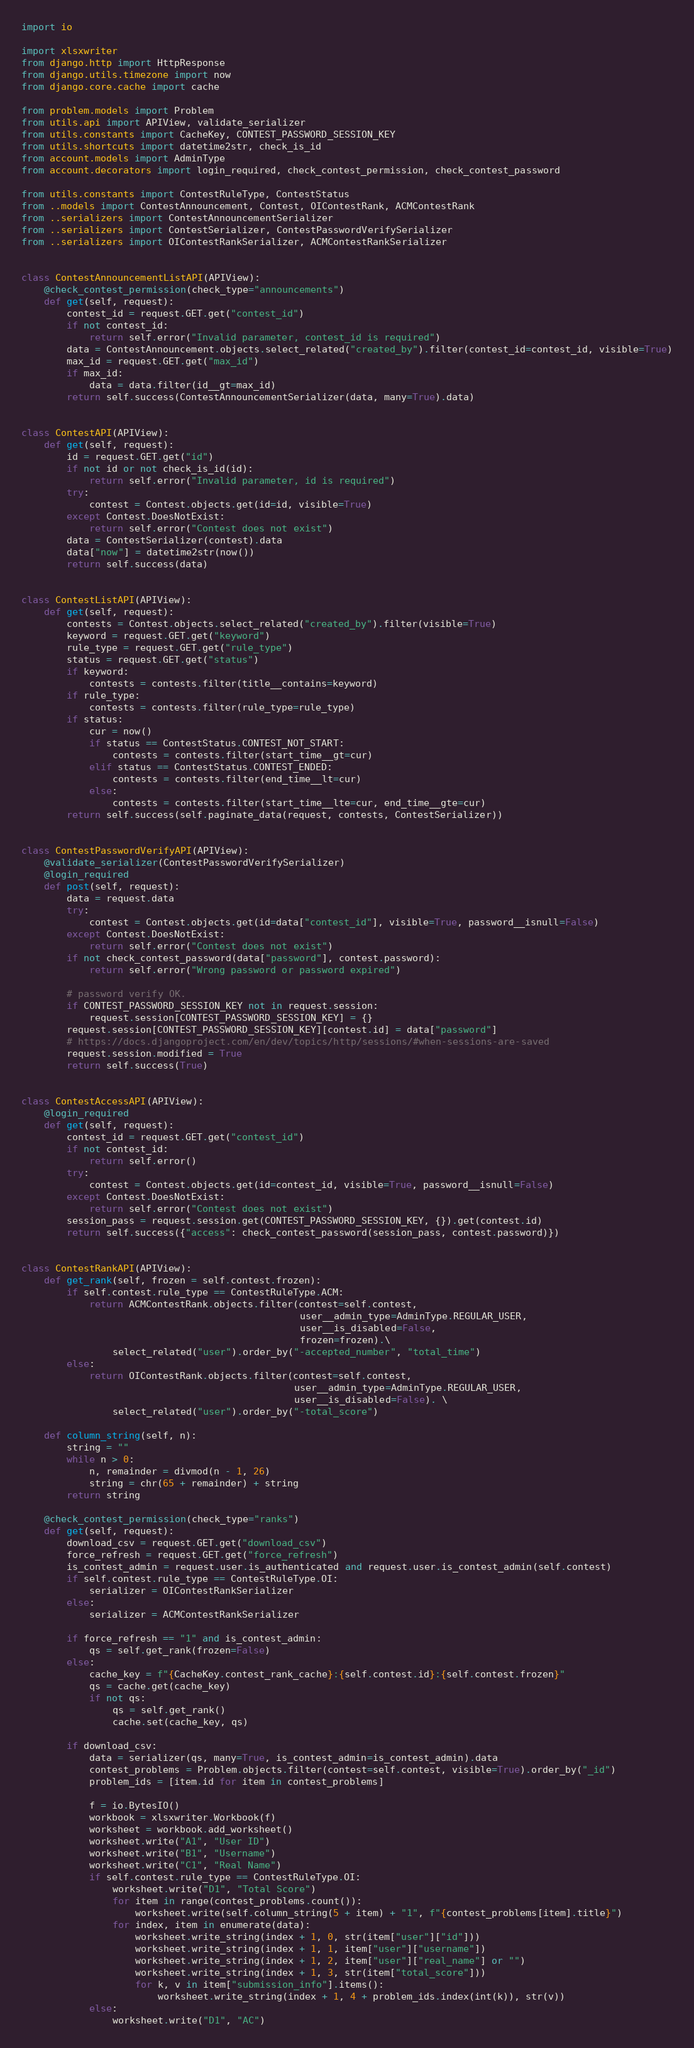<code> <loc_0><loc_0><loc_500><loc_500><_Python_>import io

import xlsxwriter
from django.http import HttpResponse
from django.utils.timezone import now
from django.core.cache import cache

from problem.models import Problem
from utils.api import APIView, validate_serializer
from utils.constants import CacheKey, CONTEST_PASSWORD_SESSION_KEY
from utils.shortcuts import datetime2str, check_is_id
from account.models import AdminType
from account.decorators import login_required, check_contest_permission, check_contest_password

from utils.constants import ContestRuleType, ContestStatus
from ..models import ContestAnnouncement, Contest, OIContestRank, ACMContestRank
from ..serializers import ContestAnnouncementSerializer
from ..serializers import ContestSerializer, ContestPasswordVerifySerializer
from ..serializers import OIContestRankSerializer, ACMContestRankSerializer


class ContestAnnouncementListAPI(APIView):
    @check_contest_permission(check_type="announcements")
    def get(self, request):
        contest_id = request.GET.get("contest_id")
        if not contest_id:
            return self.error("Invalid parameter, contest_id is required")
        data = ContestAnnouncement.objects.select_related("created_by").filter(contest_id=contest_id, visible=True)
        max_id = request.GET.get("max_id")
        if max_id:
            data = data.filter(id__gt=max_id)
        return self.success(ContestAnnouncementSerializer(data, many=True).data)


class ContestAPI(APIView):
    def get(self, request):
        id = request.GET.get("id")
        if not id or not check_is_id(id):
            return self.error("Invalid parameter, id is required")
        try:
            contest = Contest.objects.get(id=id, visible=True)
        except Contest.DoesNotExist:
            return self.error("Contest does not exist")
        data = ContestSerializer(contest).data
        data["now"] = datetime2str(now())
        return self.success(data)


class ContestListAPI(APIView):
    def get(self, request):
        contests = Contest.objects.select_related("created_by").filter(visible=True)
        keyword = request.GET.get("keyword")
        rule_type = request.GET.get("rule_type")
        status = request.GET.get("status")
        if keyword:
            contests = contests.filter(title__contains=keyword)
        if rule_type:
            contests = contests.filter(rule_type=rule_type)
        if status:
            cur = now()
            if status == ContestStatus.CONTEST_NOT_START:
                contests = contests.filter(start_time__gt=cur)
            elif status == ContestStatus.CONTEST_ENDED:
                contests = contests.filter(end_time__lt=cur)
            else:
                contests = contests.filter(start_time__lte=cur, end_time__gte=cur)
        return self.success(self.paginate_data(request, contests, ContestSerializer))


class ContestPasswordVerifyAPI(APIView):
    @validate_serializer(ContestPasswordVerifySerializer)
    @login_required
    def post(self, request):
        data = request.data
        try:
            contest = Contest.objects.get(id=data["contest_id"], visible=True, password__isnull=False)
        except Contest.DoesNotExist:
            return self.error("Contest does not exist")
        if not check_contest_password(data["password"], contest.password):
            return self.error("Wrong password or password expired")

        # password verify OK.
        if CONTEST_PASSWORD_SESSION_KEY not in request.session:
            request.session[CONTEST_PASSWORD_SESSION_KEY] = {}
        request.session[CONTEST_PASSWORD_SESSION_KEY][contest.id] = data["password"]
        # https://docs.djangoproject.com/en/dev/topics/http/sessions/#when-sessions-are-saved
        request.session.modified = True
        return self.success(True)


class ContestAccessAPI(APIView):
    @login_required
    def get(self, request):
        contest_id = request.GET.get("contest_id")
        if not contest_id:
            return self.error()
        try:
            contest = Contest.objects.get(id=contest_id, visible=True, password__isnull=False)
        except Contest.DoesNotExist:
            return self.error("Contest does not exist")
        session_pass = request.session.get(CONTEST_PASSWORD_SESSION_KEY, {}).get(contest.id)
        return self.success({"access": check_contest_password(session_pass, contest.password)})


class ContestRankAPI(APIView):
    def get_rank(self, frozen = self.contest.frozen):
        if self.contest.rule_type == ContestRuleType.ACM:
            return ACMContestRank.objects.filter(contest=self.contest,
                                                 user__admin_type=AdminType.REGULAR_USER,
                                                 user__is_disabled=False,
                                                 frozen=frozen).\
                select_related("user").order_by("-accepted_number", "total_time")
        else:
            return OIContestRank.objects.filter(contest=self.contest,
                                                user__admin_type=AdminType.REGULAR_USER,
                                                user__is_disabled=False). \
                select_related("user").order_by("-total_score")

    def column_string(self, n):
        string = ""
        while n > 0:
            n, remainder = divmod(n - 1, 26)
            string = chr(65 + remainder) + string
        return string

    @check_contest_permission(check_type="ranks")
    def get(self, request):
        download_csv = request.GET.get("download_csv")
        force_refresh = request.GET.get("force_refresh")
        is_contest_admin = request.user.is_authenticated and request.user.is_contest_admin(self.contest)
        if self.contest.rule_type == ContestRuleType.OI:
            serializer = OIContestRankSerializer
        else:
            serializer = ACMContestRankSerializer

        if force_refresh == "1" and is_contest_admin:
            qs = self.get_rank(frozen=False)
        else:
            cache_key = f"{CacheKey.contest_rank_cache}:{self.contest.id}:{self.contest.frozen}"
            qs = cache.get(cache_key)
            if not qs:
                qs = self.get_rank()
                cache.set(cache_key, qs)

        if download_csv:
            data = serializer(qs, many=True, is_contest_admin=is_contest_admin).data
            contest_problems = Problem.objects.filter(contest=self.contest, visible=True).order_by("_id")
            problem_ids = [item.id for item in contest_problems]

            f = io.BytesIO()
            workbook = xlsxwriter.Workbook(f)
            worksheet = workbook.add_worksheet()
            worksheet.write("A1", "User ID")
            worksheet.write("B1", "Username")
            worksheet.write("C1", "Real Name")
            if self.contest.rule_type == ContestRuleType.OI:
                worksheet.write("D1", "Total Score")
                for item in range(contest_problems.count()):
                    worksheet.write(self.column_string(5 + item) + "1", f"{contest_problems[item].title}")
                for index, item in enumerate(data):
                    worksheet.write_string(index + 1, 0, str(item["user"]["id"]))
                    worksheet.write_string(index + 1, 1, item["user"]["username"])
                    worksheet.write_string(index + 1, 2, item["user"]["real_name"] or "")
                    worksheet.write_string(index + 1, 3, str(item["total_score"]))
                    for k, v in item["submission_info"].items():
                        worksheet.write_string(index + 1, 4 + problem_ids.index(int(k)), str(v))
            else:
                worksheet.write("D1", "AC")</code> 